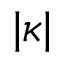Convert formula to latex. <formula><loc_0><loc_0><loc_500><loc_500>| \kappa |</formula> 